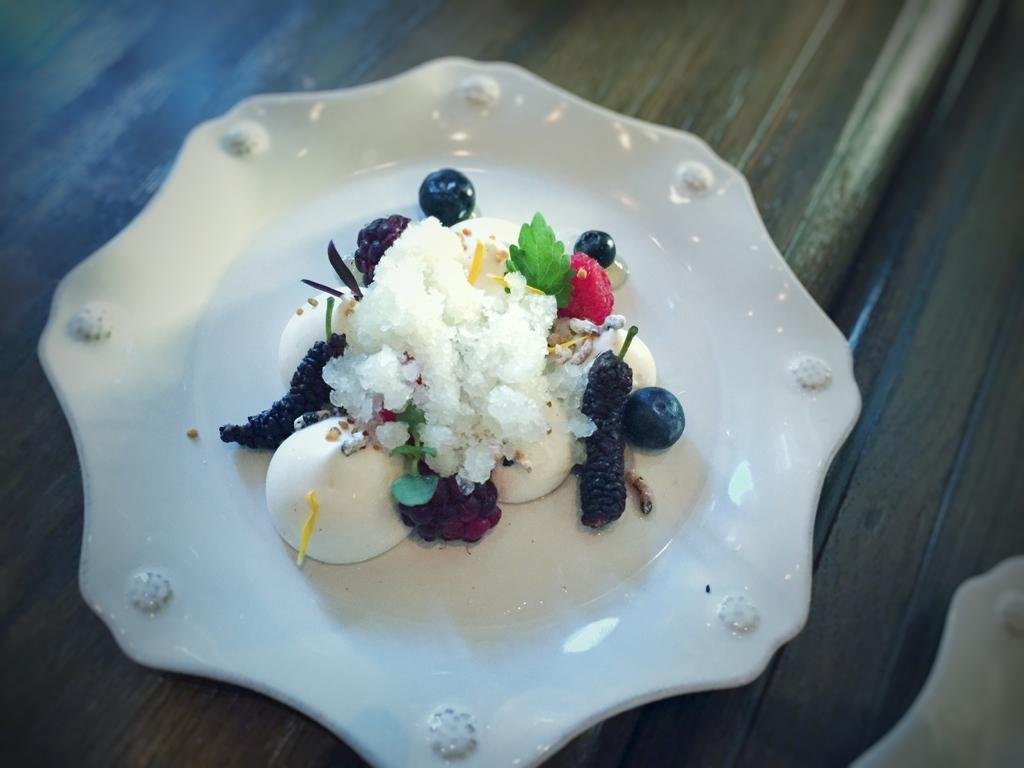What is on the plate that is visible in the image? There are food items in a plate in the image. Where is the plate located? The plate is on a table in the image. How is the plate and food items positioned in the image? The food items and plate are in the center of the image. How many bikes are parked next to the table in the image? There is no bike present in the image. Is the bat holding a ball in the image? There is no bat or ball present in the image. 